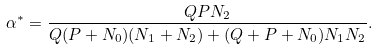Convert formula to latex. <formula><loc_0><loc_0><loc_500><loc_500>\alpha ^ { * } = \frac { Q P { N _ { 2 } } } { Q ( P + N _ { 0 } ) ( { N _ { 1 } } + { N _ { 2 } } ) + ( Q + P + N _ { 0 } ) { N _ { 1 } N _ { 2 } } } .</formula> 